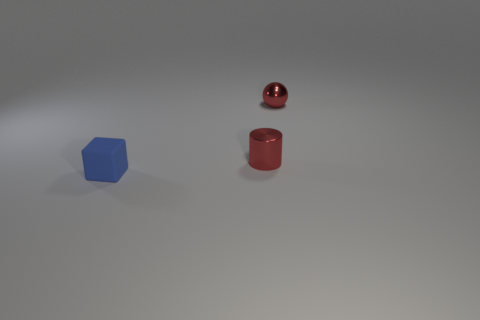Add 1 tiny purple metal spheres. How many objects exist? 4 Subtract all cubes. How many objects are left? 2 Subtract 0 green spheres. How many objects are left? 3 Subtract all tiny blue things. Subtract all small metal cylinders. How many objects are left? 1 Add 1 red cylinders. How many red cylinders are left? 2 Add 2 tiny metal spheres. How many tiny metal spheres exist? 3 